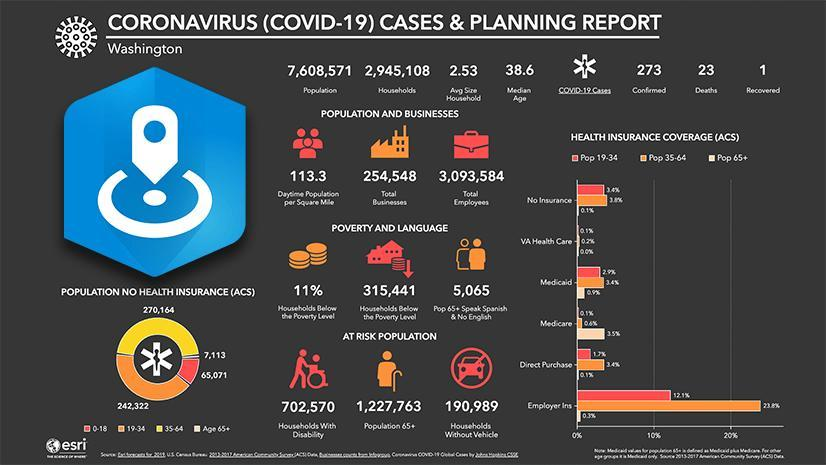What percentage of households are below the poverty line in Washington?
Answer the question with a short phrase. 11% What is the population of senior citizens at risk in Washington? 1,227,763 What is the population in the age group of 35-64 without health insurance (ACS)? 270,164 How many recovered cases of Covid-19 are there out of 273 confirmed ones in Washington? 1 What is the number of households below the poverty line in Washington? 315,441 What is the number of households with disabled people in Washington? 702,570 What is the population of senior citizens who speaks Spanish & no english in Washington? 5,065 What is the total number of confirmed covid-19 positive cases in Washington? 273 What is the population of  senior citizens without health insurance (ACS)? 7,113 What is the number of Covid-19 deaths in Washington? 23 